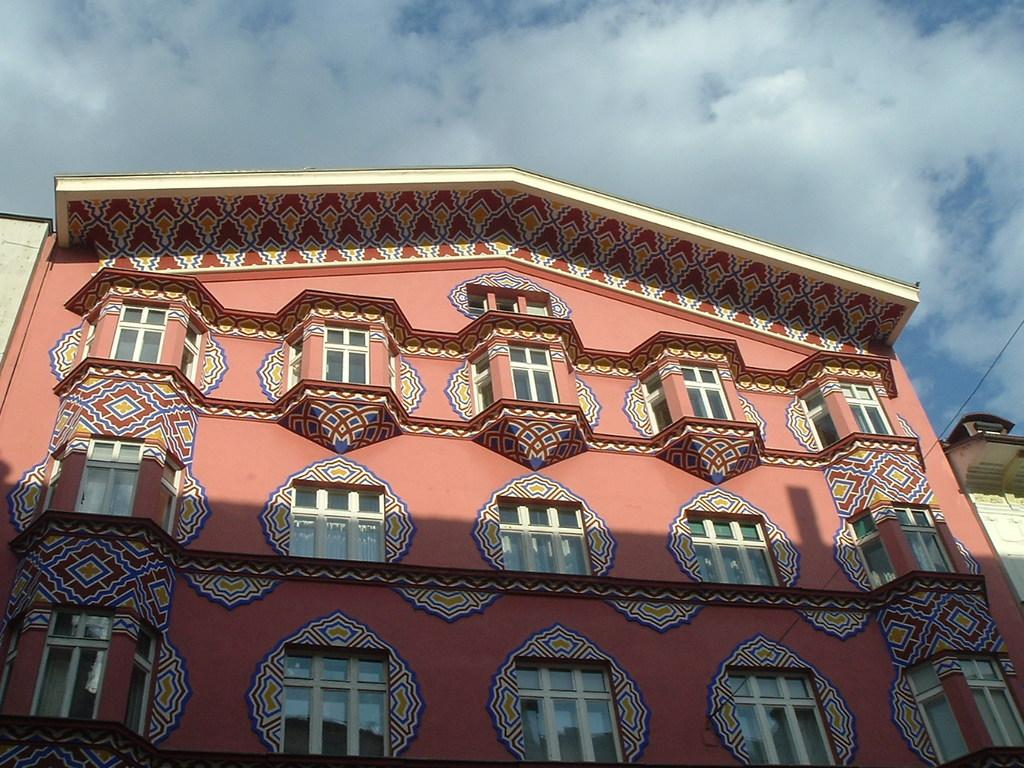What is the main structure in the picture? There is a building in the picture. What can be seen at the top of the picture? The sky is visible at the top of the picture. What is present in the sky? There are clouds in the sky. What feature can be observed on the building? The building has windows. What type of animal is making a joke in the picture? There is no animal or joke present in the picture; it features a building with windows and clouds in the sky. 